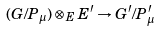Convert formula to latex. <formula><loc_0><loc_0><loc_500><loc_500>( G / P _ { \mu } ) \otimes _ { E } E ^ { \prime } \to G ^ { \prime } / P ^ { \prime } _ { \mu } \</formula> 